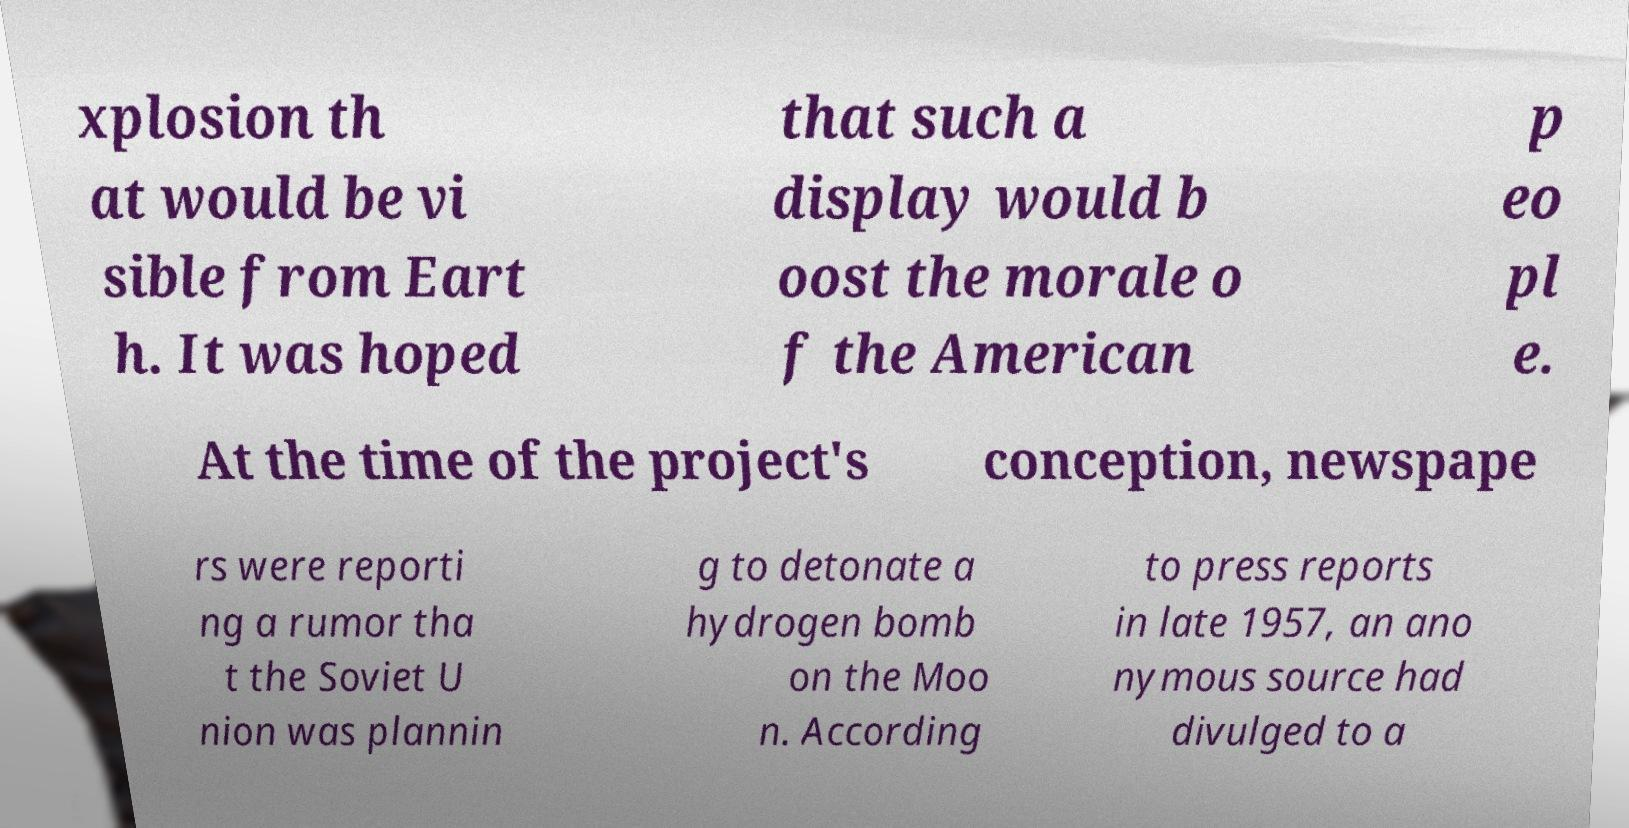Please identify and transcribe the text found in this image. xplosion th at would be vi sible from Eart h. It was hoped that such a display would b oost the morale o f the American p eo pl e. At the time of the project's conception, newspape rs were reporti ng a rumor tha t the Soviet U nion was plannin g to detonate a hydrogen bomb on the Moo n. According to press reports in late 1957, an ano nymous source had divulged to a 